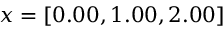<formula> <loc_0><loc_0><loc_500><loc_500>x = [ 0 . 0 0 , 1 . 0 0 , 2 . 0 0 ]</formula> 